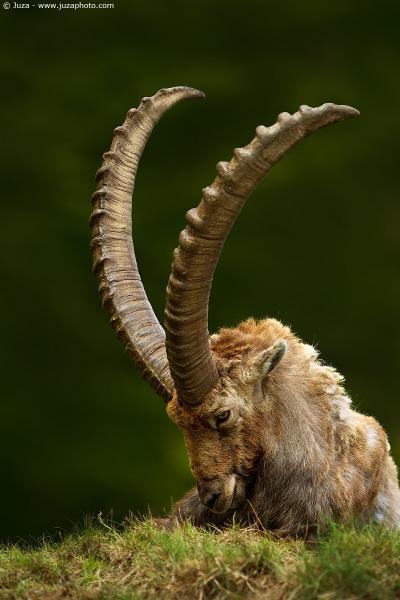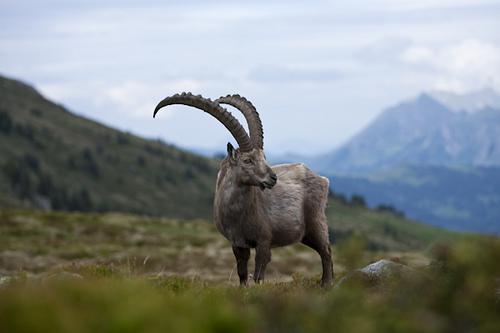The first image is the image on the left, the second image is the image on the right. Examine the images to the left and right. Is the description "One image contains more than one animal." accurate? Answer yes or no. No. The first image is the image on the left, the second image is the image on the right. Assess this claim about the two images: "There is exactly one animal in the image on the right.". Correct or not? Answer yes or no. Yes. 